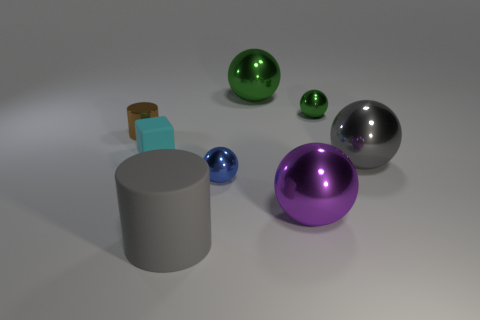How many big metal spheres are the same color as the big cylinder?
Your answer should be very brief. 1. What material is the sphere that is the same color as the big matte cylinder?
Your answer should be very brief. Metal. Is the number of green objects that are in front of the tiny cylinder greater than the number of small red rubber cylinders?
Ensure brevity in your answer.  No. Do the small green object and the small cyan thing have the same shape?
Keep it short and to the point. No. How many brown cylinders have the same material as the small cyan cube?
Ensure brevity in your answer.  0. The other thing that is the same shape as the tiny brown metallic thing is what size?
Keep it short and to the point. Large. Is the size of the gray matte cylinder the same as the cube?
Ensure brevity in your answer.  No. What is the shape of the tiny metal thing that is on the right side of the tiny metallic object in front of the shiny thing to the left of the cyan matte thing?
Provide a short and direct response. Sphere. The other object that is the same shape as the small brown shiny thing is what color?
Provide a succinct answer. Gray. How big is the ball that is both to the left of the tiny green metal sphere and behind the cube?
Ensure brevity in your answer.  Large. 